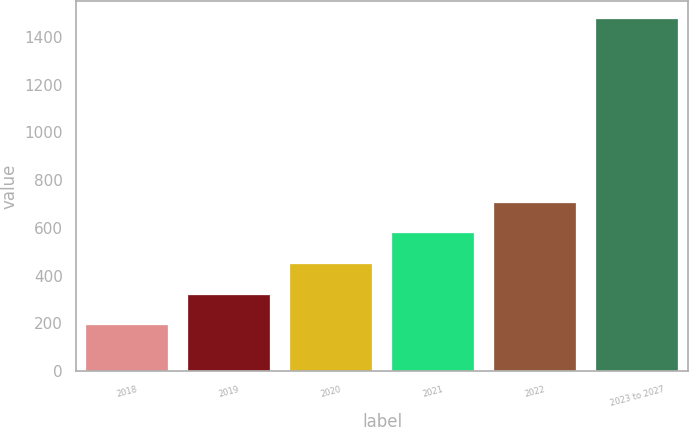Convert chart to OTSL. <chart><loc_0><loc_0><loc_500><loc_500><bar_chart><fcel>2018<fcel>2019<fcel>2020<fcel>2021<fcel>2022<fcel>2023 to 2027<nl><fcel>192<fcel>320.2<fcel>448.4<fcel>576.6<fcel>704.8<fcel>1474<nl></chart> 